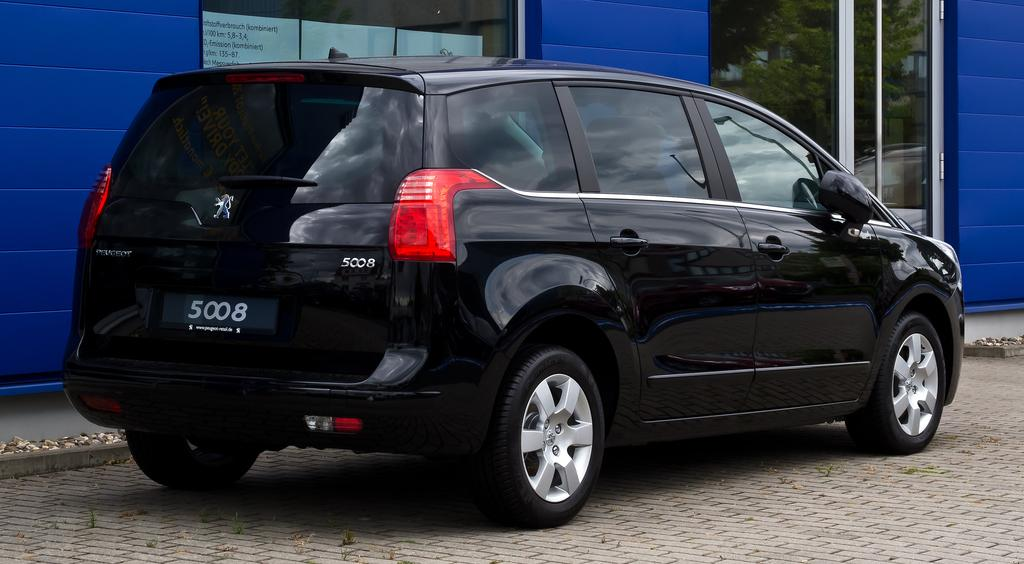What color is the car in the image? The car in the image is black. Where is the car located in the image? The car is on the ground. What can be seen reflected in the car's surface? There is a mirror image of trees in the image. What type of objects are present on the walls in the image? There are posters in the image. What is written on the posters? There is text written on the posters. What type of material is used for the windows in the image? There are glass windows in the image. How much does the car weigh in the image? The weight of the car cannot be determined from the image alone, as it depends on the car's make and model. 